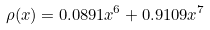Convert formula to latex. <formula><loc_0><loc_0><loc_500><loc_500>\rho ( x ) = 0 . 0 8 9 1 x ^ { 6 } + 0 . 9 1 0 9 x ^ { 7 }</formula> 